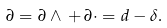Convert formula to latex. <formula><loc_0><loc_0><loc_500><loc_500>\partial = \partial \wedge \, + \, \partial \cdot = d - \delta .</formula> 